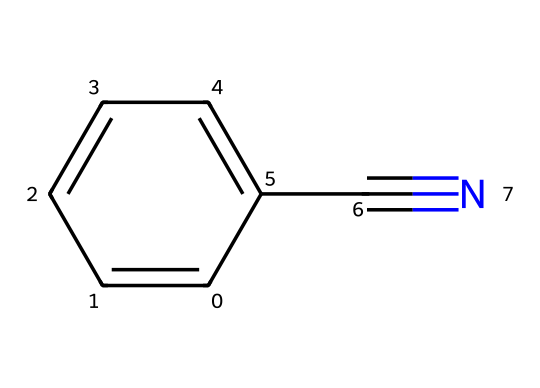What is the name of this compound? The SMILES representation indicates a benzene ring (c1ccccc1) attached to a nitrile group (C#N), which together identifies the compound as benzonitrile.
Answer: benzonitrile How many carbon atoms are present in this molecule? Analyzing the structure, there are six carbon atoms in the benzene ring and one additional carbon from the nitrile group, totaling seven carbon atoms.
Answer: 7 How many nitrogen atoms are in this compound? From the SMILES representation, there is only one nitrogen atom present in the nitrile group (C#N).
Answer: 1 What kind of functional group is present in benzonitrile? The nitrile group (C#N) is present in this molecule, which classifies it as a nitrile functional group.
Answer: nitrile What is the primary aromatic structure present? The presence of the benzene ring (c1ccccc1) in the compound indicates that the primary structure is aromatic.
Answer: aromatic Is benzonitrile a saturated or unsaturated compound? Evaluating the molecular structure reveals that the presence of the triple bond in the nitrile group indicates that benzonitrile is an unsaturated compound.
Answer: unsaturated 